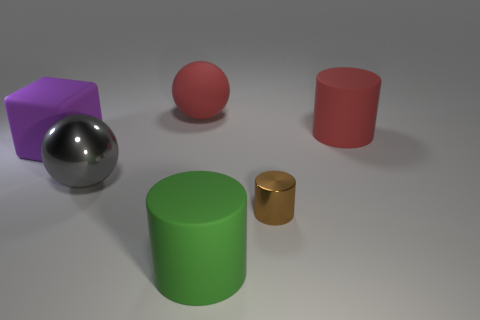There is a matte thing that is the same color as the rubber sphere; what shape is it?
Keep it short and to the point. Cylinder. How many big gray metal objects are there?
Your answer should be compact. 1. How many large matte things have the same color as the matte ball?
Make the answer very short. 1. Do the green rubber object and the big purple matte thing have the same shape?
Keep it short and to the point. No. There is a metallic object that is left of the red object behind the large red rubber cylinder; how big is it?
Offer a very short reply. Large. Are there any purple metallic cubes that have the same size as the rubber sphere?
Keep it short and to the point. No. Do the matte cylinder behind the rubber cube and the red object that is left of the large green cylinder have the same size?
Offer a terse response. Yes. There is a big red rubber object that is to the right of the rubber object that is behind the red rubber cylinder; what shape is it?
Offer a very short reply. Cylinder. There is a big purple matte block; what number of large cylinders are on the right side of it?
Make the answer very short. 2. The sphere that is the same material as the large purple block is what color?
Make the answer very short. Red. 